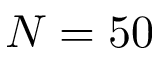Convert formula to latex. <formula><loc_0><loc_0><loc_500><loc_500>N = 5 0</formula> 